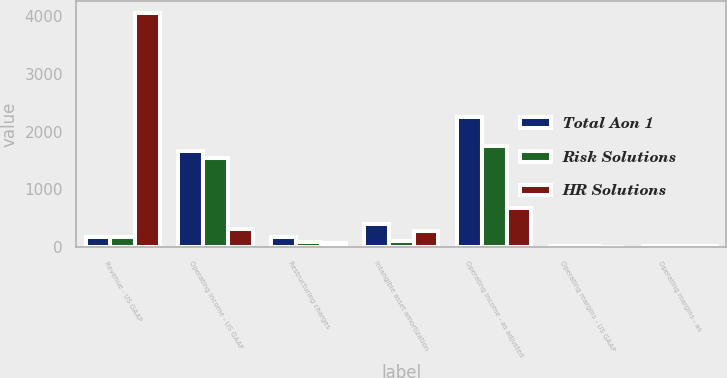<chart> <loc_0><loc_0><loc_500><loc_500><stacked_bar_chart><ecel><fcel>Revenue - US GAAP<fcel>Operating income - US GAAP<fcel>Restructuring charges<fcel>Intangible asset amortization<fcel>Operating income - as adjusted<fcel>Operating margins - US GAAP<fcel>Operating margins - as<nl><fcel>Total Aon 1<fcel>174<fcel>1671<fcel>174<fcel>395<fcel>2245<fcel>14.1<fcel>19<nl><fcel>Risk Solutions<fcel>174<fcel>1540<fcel>94<fcel>115<fcel>1749<fcel>19.8<fcel>22.5<nl><fcel>HR Solutions<fcel>4057<fcel>318<fcel>80<fcel>280<fcel>678<fcel>7.8<fcel>16.7<nl></chart> 